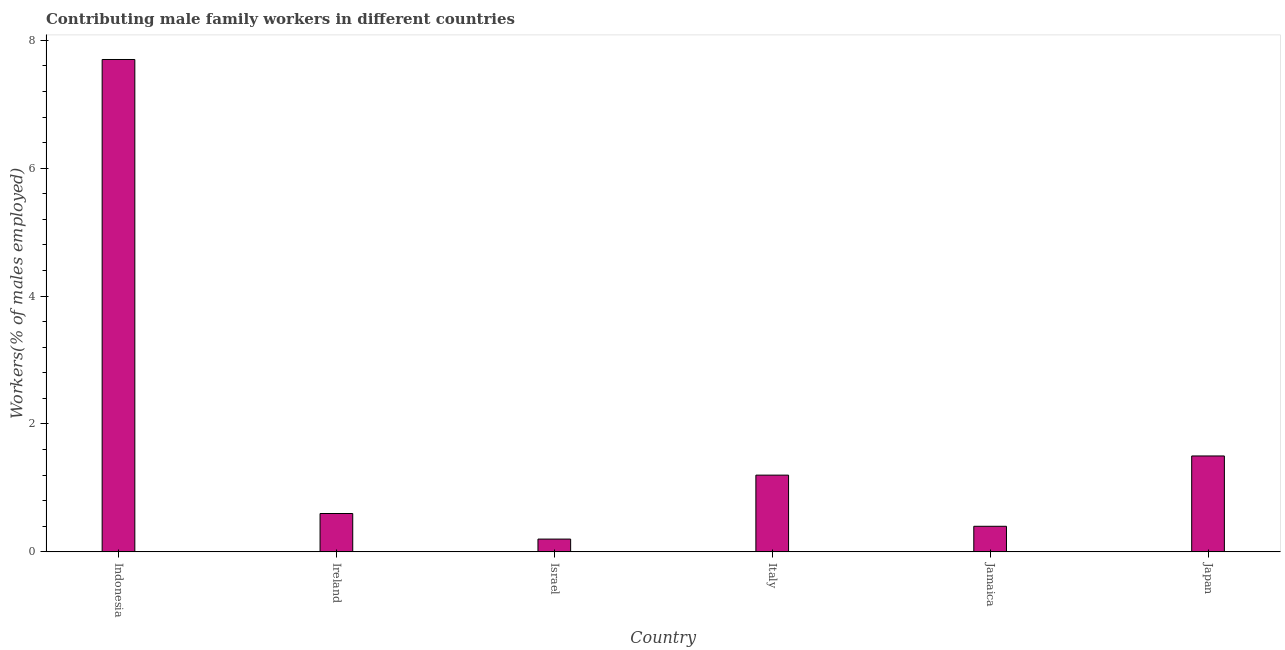Does the graph contain grids?
Offer a very short reply. No. What is the title of the graph?
Keep it short and to the point. Contributing male family workers in different countries. What is the label or title of the Y-axis?
Ensure brevity in your answer.  Workers(% of males employed). What is the contributing male family workers in Indonesia?
Offer a very short reply. 7.7. Across all countries, what is the maximum contributing male family workers?
Ensure brevity in your answer.  7.7. Across all countries, what is the minimum contributing male family workers?
Your answer should be compact. 0.2. In which country was the contributing male family workers maximum?
Make the answer very short. Indonesia. What is the sum of the contributing male family workers?
Your response must be concise. 11.6. What is the average contributing male family workers per country?
Your answer should be compact. 1.93. What is the median contributing male family workers?
Ensure brevity in your answer.  0.9. In how many countries, is the contributing male family workers greater than 7.6 %?
Provide a short and direct response. 1. What is the ratio of the contributing male family workers in Indonesia to that in Italy?
Offer a terse response. 6.42. In how many countries, is the contributing male family workers greater than the average contributing male family workers taken over all countries?
Provide a short and direct response. 1. How many bars are there?
Provide a succinct answer. 6. What is the difference between two consecutive major ticks on the Y-axis?
Offer a terse response. 2. Are the values on the major ticks of Y-axis written in scientific E-notation?
Offer a very short reply. No. What is the Workers(% of males employed) of Indonesia?
Give a very brief answer. 7.7. What is the Workers(% of males employed) in Ireland?
Your answer should be compact. 0.6. What is the Workers(% of males employed) of Israel?
Offer a terse response. 0.2. What is the Workers(% of males employed) in Italy?
Ensure brevity in your answer.  1.2. What is the Workers(% of males employed) in Jamaica?
Your response must be concise. 0.4. What is the Workers(% of males employed) of Japan?
Give a very brief answer. 1.5. What is the difference between the Workers(% of males employed) in Indonesia and Ireland?
Offer a very short reply. 7.1. What is the difference between the Workers(% of males employed) in Indonesia and Israel?
Make the answer very short. 7.5. What is the difference between the Workers(% of males employed) in Indonesia and Jamaica?
Give a very brief answer. 7.3. What is the difference between the Workers(% of males employed) in Indonesia and Japan?
Your answer should be compact. 6.2. What is the difference between the Workers(% of males employed) in Israel and Italy?
Give a very brief answer. -1. What is the difference between the Workers(% of males employed) in Israel and Japan?
Ensure brevity in your answer.  -1.3. What is the ratio of the Workers(% of males employed) in Indonesia to that in Ireland?
Your answer should be very brief. 12.83. What is the ratio of the Workers(% of males employed) in Indonesia to that in Israel?
Provide a succinct answer. 38.5. What is the ratio of the Workers(% of males employed) in Indonesia to that in Italy?
Your answer should be very brief. 6.42. What is the ratio of the Workers(% of males employed) in Indonesia to that in Jamaica?
Your answer should be compact. 19.25. What is the ratio of the Workers(% of males employed) in Indonesia to that in Japan?
Your answer should be very brief. 5.13. What is the ratio of the Workers(% of males employed) in Ireland to that in Israel?
Offer a terse response. 3. What is the ratio of the Workers(% of males employed) in Ireland to that in Italy?
Keep it short and to the point. 0.5. What is the ratio of the Workers(% of males employed) in Ireland to that in Jamaica?
Give a very brief answer. 1.5. What is the ratio of the Workers(% of males employed) in Ireland to that in Japan?
Your answer should be very brief. 0.4. What is the ratio of the Workers(% of males employed) in Israel to that in Italy?
Make the answer very short. 0.17. What is the ratio of the Workers(% of males employed) in Israel to that in Japan?
Your answer should be compact. 0.13. What is the ratio of the Workers(% of males employed) in Jamaica to that in Japan?
Ensure brevity in your answer.  0.27. 